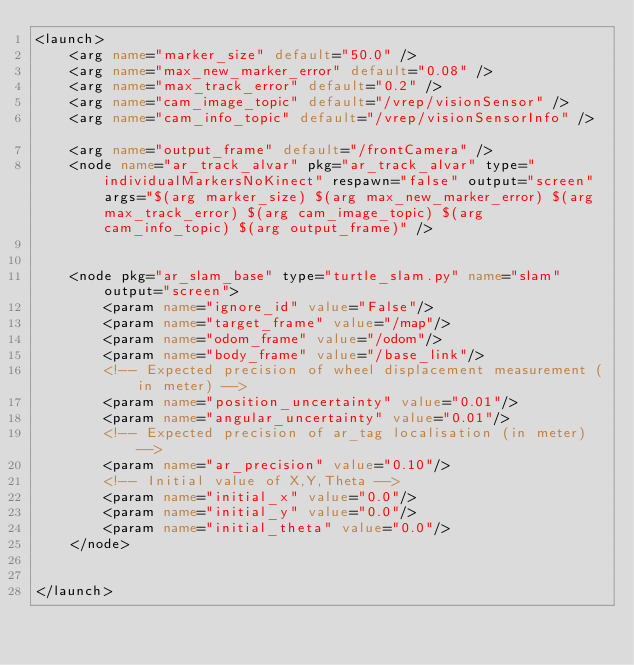Convert code to text. <code><loc_0><loc_0><loc_500><loc_500><_XML_><launch>
	<arg name="marker_size" default="50.0" />
	<arg name="max_new_marker_error" default="0.08" />
	<arg name="max_track_error" default="0.2" />
	<arg name="cam_image_topic" default="/vrep/visionSensor" />
    <arg name="cam_info_topic" default="/vrep/visionSensorInfo" />	
	<arg name="output_frame" default="/frontCamera" />
	<node name="ar_track_alvar" pkg="ar_track_alvar" type="individualMarkersNoKinect" respawn="false" output="screen" args="$(arg marker_size) $(arg max_new_marker_error) $(arg max_track_error) $(arg cam_image_topic) $(arg cam_info_topic) $(arg output_frame)" />


    <node pkg="ar_slam_base" type="turtle_slam.py" name="slam" output="screen">
        <param name="ignore_id" value="False"/>
        <param name="target_frame" value="/map"/>
        <param name="odom_frame" value="/odom"/>
        <param name="body_frame" value="/base_link"/>
        <!-- Expected precision of wheel displacement measurement (in meter) -->
        <param name="position_uncertainty" value="0.01"/>
        <param name="angular_uncertainty" value="0.01"/>
        <!-- Expected precision of ar_tag localisation (in meter) -->
        <param name="ar_precision" value="0.10"/>
        <!-- Initial value of X,Y,Theta -->
        <param name="initial_x" value="0.0"/>
        <param name="initial_y" value="0.0"/>
        <param name="initial_theta" value="0.0"/>
    </node>


</launch>
</code> 